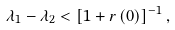Convert formula to latex. <formula><loc_0><loc_0><loc_500><loc_500>\lambda _ { 1 } - \lambda _ { 2 } < \left [ 1 + r \left ( 0 \right ) \right ] ^ { - 1 } ,</formula> 